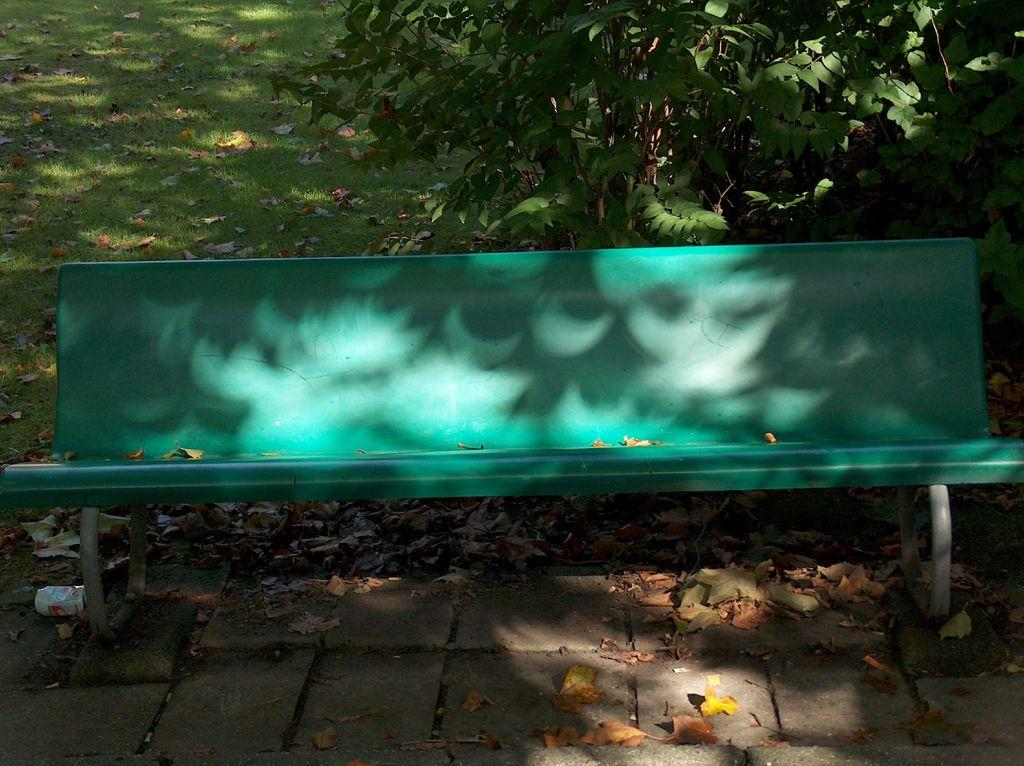What can be found on the floor at the bottom of the image? There are dry leaves on the floor at the bottom of the image. What type of seating is visible in the image? There is a green bench in the image. What is located behind the bench? There is a tree behind the bench. What type of vegetation is present on the ground? There is grass on the ground with dry leaves. What type of shelf can be seen in the image? There is no shelf present in the image. What is the smell of the dry leaves in the image? The image does not provide information about the smell of the dry leaves, as it is a visual medium. 